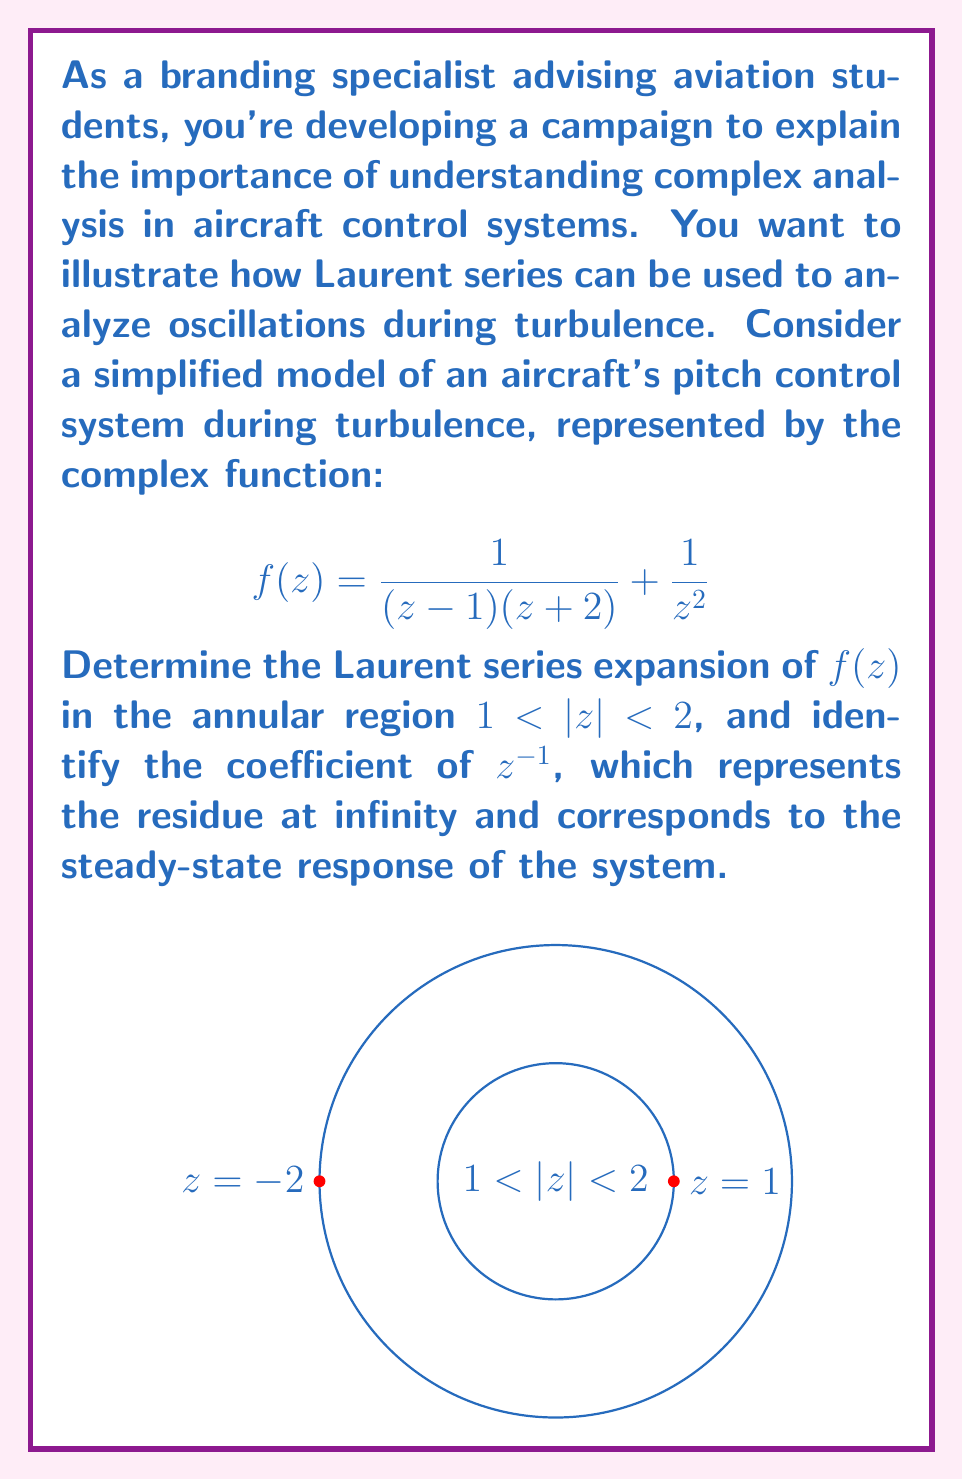What is the answer to this math problem? To solve this problem, we'll follow these steps:

1) First, we need to split the function into partial fractions:

   $$f(z) = \frac{1}{(z-1)(z+2)} + \frac{1}{z^2}$$
   $$= \frac{A}{z-1} + \frac{B}{z+2} + \frac{1}{z^2}$$

   Where $A$ and $B$ are constants to be determined.

2) Multiply both sides by $(z-1)(z+2)$:

   $1 = A(z+2) + B(z-1)$

3) Solve for $A$ and $B$:
   
   When $z = 1$: $1 = A(3) \Rightarrow A = \frac{1}{3}$
   When $z = -2$: $1 = B(-3) \Rightarrow B = -\frac{1}{3}$

4) Now we have:

   $$f(z) = \frac{1/3}{z-1} - \frac{1/3}{z+2} + \frac{1}{z^2}$$

5) For the region $1 < |z| < 2$, we need to expand each term:

   For $\frac{1/3}{z-1}$: $$\frac{1/3}{z-1} = -\frac{1}{3z} \cdot \frac{1}{1-\frac{1}{z}} = -\frac{1}{3z}(1 + \frac{1}{z} + \frac{1}{z^2} + ...)$$

   For $-\frac{1/3}{z+2}$: $$-\frac{1/3}{z+2} = -\frac{1}{3z} \cdot \frac{1}{1+\frac{2}{z}} = -\frac{1}{3z}(1 - \frac{2}{z} + \frac{4}{z^2} - ...)$$

   $\frac{1}{z^2}$ is already in the correct form.

6) Combining these expansions:

   $$f(z) = (-\frac{1}{3z} - \frac{1}{3z^2} - \frac{1}{3z^3} - ...) + (-\frac{1}{3z} + \frac{2}{3z^2} - \frac{4}{3z^3} + ...) + \frac{1}{z^2}$$

7) Simplifying and collecting terms:

   $$f(z) = -\frac{2}{3z} + (\frac{2}{3} + 1)\frac{1}{z^2} + (-\frac{1}{3} - \frac{4}{3})\frac{1}{z^3} + ...$$
   
   $$= -\frac{2}{3z} + \frac{5}{3z^2} - \frac{5}{3z^3} + ...$$

8) The coefficient of $z^{-1}$ (which is the residue at infinity) is $-\frac{2}{3}$.
Answer: $-\frac{2}{3}$ 